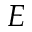<formula> <loc_0><loc_0><loc_500><loc_500>E</formula> 